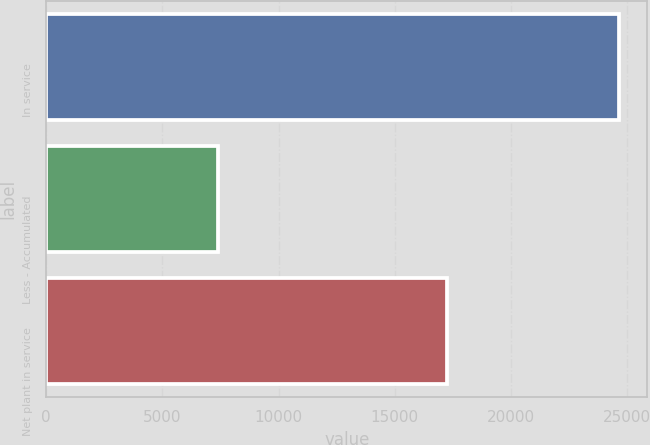<chart> <loc_0><loc_0><loc_500><loc_500><bar_chart><fcel>In service<fcel>Less - Accumulated<fcel>Net plant in service<nl><fcel>24650<fcel>7415<fcel>17235<nl></chart> 